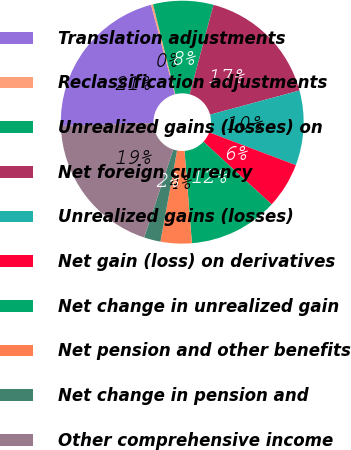Convert chart to OTSL. <chart><loc_0><loc_0><loc_500><loc_500><pie_chart><fcel>Translation adjustments<fcel>Reclassification adjustments<fcel>Unrealized gains (losses) on<fcel>Net foreign currency<fcel>Unrealized gains (losses)<fcel>Net gain (loss) on derivatives<fcel>Net change in unrealized gain<fcel>Net pension and other benefits<fcel>Net change in pension and<fcel>Other comprehensive income<nl><fcel>21.36%<fcel>0.27%<fcel>8.01%<fcel>16.66%<fcel>9.95%<fcel>6.08%<fcel>11.89%<fcel>4.14%<fcel>2.2%<fcel>19.43%<nl></chart> 